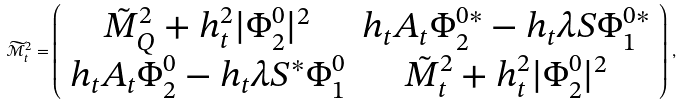<formula> <loc_0><loc_0><loc_500><loc_500>\widetilde { \mathcal { M } } ^ { 2 } _ { t } = \left ( \begin{array} { c c } \tilde { M } _ { Q } ^ { 2 } + h _ { t } ^ { 2 } | \Phi _ { 2 } ^ { 0 } | ^ { 2 } & h _ { t } A _ { t } \Phi _ { 2 } ^ { 0 \ast } - h _ { t } \lambda S \Phi _ { 1 } ^ { 0 \ast } \\ h _ { t } A _ { t } \Phi _ { 2 } ^ { 0 } - h _ { t } \lambda S ^ { \ast } \Phi _ { 1 } ^ { 0 } & \tilde { M } _ { t } ^ { 2 } + h _ { t } ^ { 2 } | \Phi _ { 2 } ^ { 0 } | ^ { 2 } \end{array} \right ) \, ,</formula> 